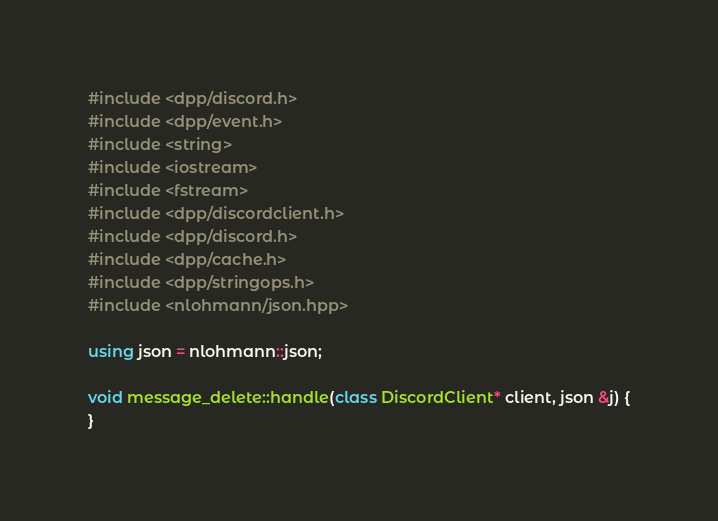Convert code to text. <code><loc_0><loc_0><loc_500><loc_500><_C++_>#include <dpp/discord.h>
#include <dpp/event.h>
#include <string>
#include <iostream>
#include <fstream>
#include <dpp/discordclient.h>
#include <dpp/discord.h>
#include <dpp/cache.h>
#include <dpp/stringops.h>
#include <nlohmann/json.hpp>

using json = nlohmann::json;

void message_delete::handle(class DiscordClient* client, json &j) {
}

</code> 